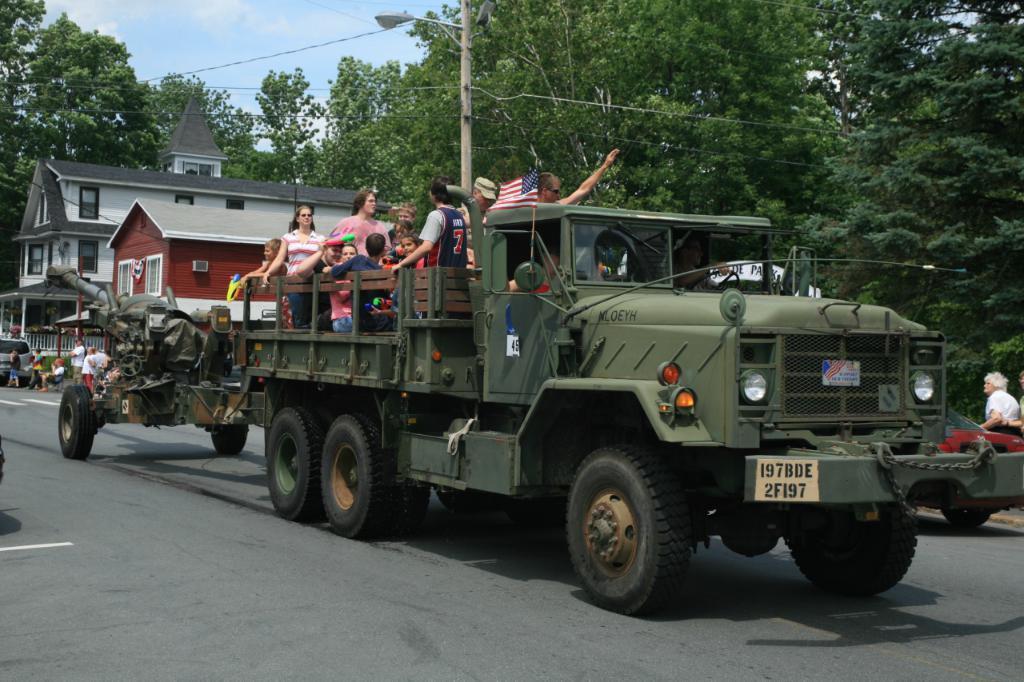Describe this image in one or two sentences. In this image we can see motor vehicles on the road and persons sitting in the carriage of one of them. In the background there are trees, street poles, street lights, electric cables, buildings, persons sitting and standing on the road, grill and sky with clouds. 